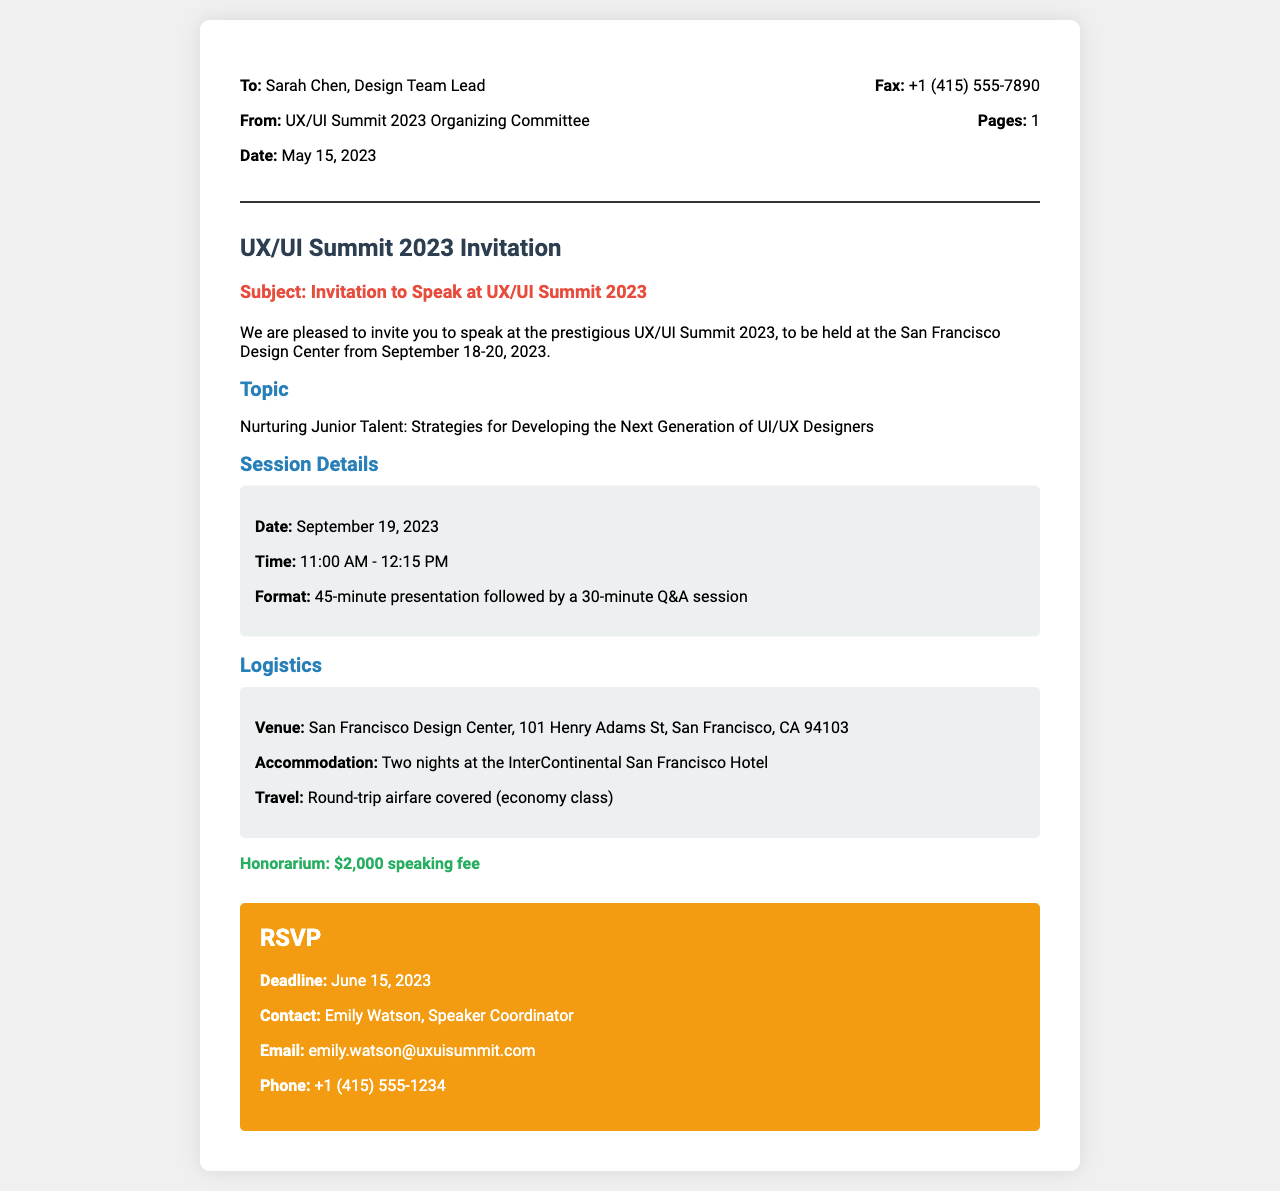what is the date of the event? The event will take place from September 18-20, 2023, with specific reference to September 19 in the session details.
Answer: September 18-20, 2023 who is the honorarium for speaking? The honorarium is mentioned as a speaking fee for the invited speaker.
Answer: $2,000 what is the format of the session? The format consists of a 45-minute presentation followed by a 30-minute Q&A session detailed under session details.
Answer: 45-minute presentation followed by a 30-minute Q&A when is the RSVP deadline? The RSVP deadline is specified in the document as the final date to respond to the invitation.
Answer: June 15, 2023 where is the venue located? The venue details provide the complete address to the San Francisco Design Center, which is essential for logistics.
Answer: San Francisco Design Center, 101 Henry Adams St, San Francisco, CA 94103 what is the topic of the talk? The topic outlines the focus of the presentation and relates to developing junior talents in the design industry.
Answer: Nurturing Junior Talent: Strategies for Developing the Next Generation of UI/UX Designers how long is the invited talk? The duration of the presentation session can be inferred from the detailed session structure provided in the document.
Answer: 45 minutes who is the contact person for the RSVP? The document specifies the name of the speaker coordinator responsible for RSVP communications.
Answer: Emily Watson 